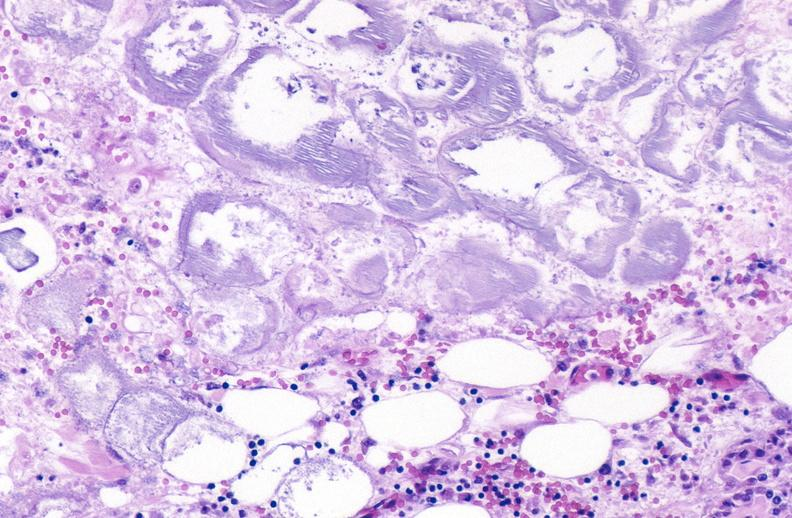what does this image show?
Answer the question using a single word or phrase. Pancreatic fat necrosis 